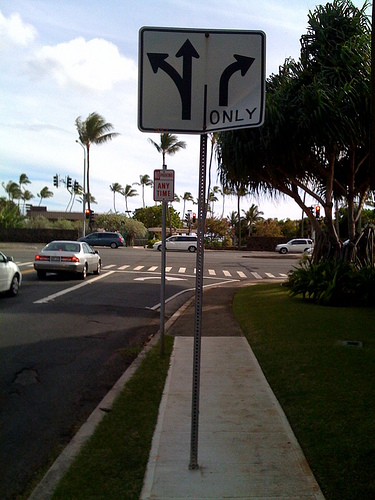Extract all visible text content from this image. ONLY ANY TIME 